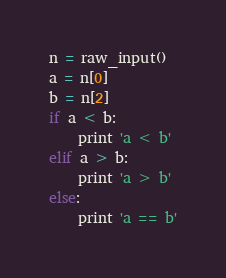<code> <loc_0><loc_0><loc_500><loc_500><_Python_>n = raw_input()
a = n[0]
b = n[2]
if a < b:
	print 'a < b'
elif a > b:
	print 'a > b'
else:
	print 'a == b'</code> 